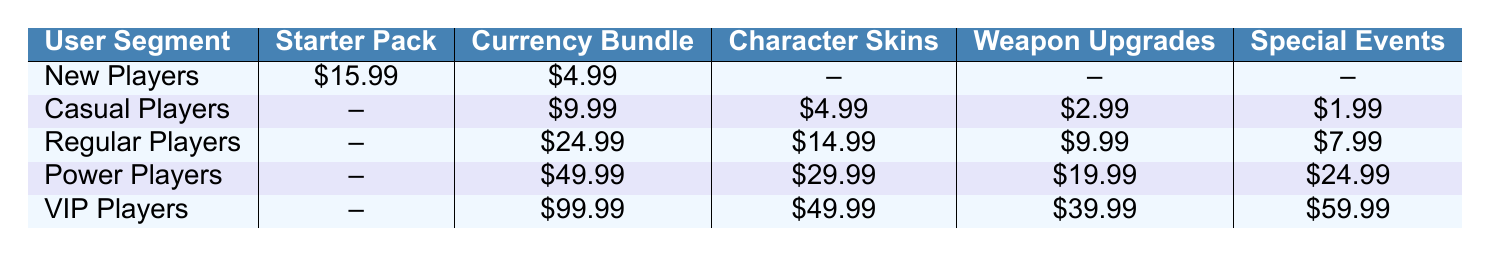What is the price of the Currency Bundle for VIP Players? From the table, the Currency Bundle for VIP Players is listed directly under their segment. It can be found in the second column corresponding to the "VIP Players" row.
Answer: $99.99 Which user segment has the highest price for Character Skins? Looking at the Character Skins column across all user segments, the highest price can be found in the row for VIP Players, where it is listed.
Answer: $49.99 Do New Players purchase any Weapon Upgrades? In the table, under the Weapon Upgrades column for New Players, the entry is shown as "--", indicating that they do not make any purchases in this category.
Answer: No What is the total amount spent on Currency Bundles across all user segments? To find the total, we sum the prices of Currency Bundles for each segment: $4.99 (New Players) + $9.99 (Casual Players) + $24.99 (Regular Players) + $49.99 (Power Players) + $99.99 (VIP Players) = $189.95.
Answer: $189.95 Is the sum of the prices for Weapon Upgrades from Casual Players and Regular Players greater than the price of the Starter Pack for New Players? The sum of Weapon Upgrades is $2.99 (Casual Players) + $9.99 (Regular Players) = $12.98, which is less than the $15.99 for the Starter Pack purchased by New Players, thus the statement is false.
Answer: No Which user segment spends the least on Special Events? In the Special Events column, we compare the values listed for each user segment. New Players have $0, which is the lowest amount spent.
Answer: New Players What is the average price of Character Skins across all user segments? The prices for Character Skins from the table are $0 (New Players), $4.99 (Casual Players), $14.99 (Regular Players), $29.99 (Power Players), and $49.99 (VIP Players). To calculate the average, we sum these values ($0 + $4.99 + $14.99 + $29.99 + $49.99 = $99.96) and divide by the number of segments (5), which gives $99.96 / 5 = $19.992.
Answer: $19.99 Which user segment has the lowest total spending on in-app purchases? To find the total spending for each segment, we add up the prices across all purchase types. New Players total $15.99 + $4.99 = $20.98, Casual Players total $9.99 + $4.99 + $2.99 + $1.99 = $19.96, and summing for others gives $24.99 + $14.99 + $9.99 + $7.99 for Regular Players, and so forth. The lowest total overall is found with Casual Players.
Answer: Casual Players What is the overall trend in in-app purchases as user segments progress from New Players to VIP Players? Analyzing the data from each row, it’s evident that as users progress from New Players to VIP Players, spending generally increases across all categories, indicating increased investment in the game with more engagement levels.
Answer: Spending increases with user engagement 